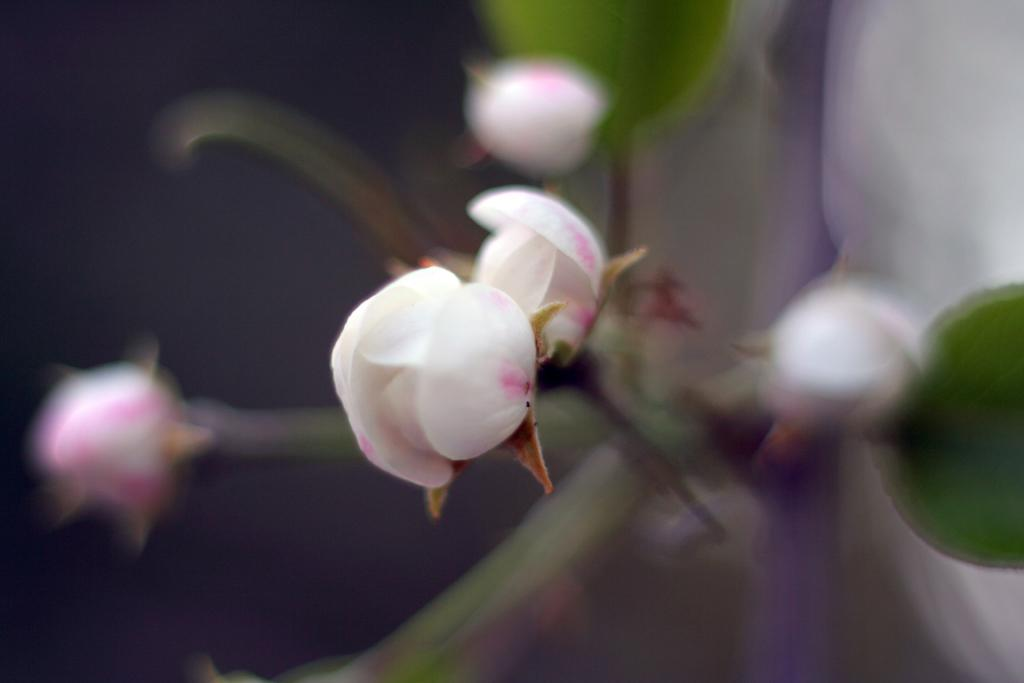What type of living organisms can be seen in the image? There are flowers and a plant visible in the image. What is the color of the background in the image? The background of the image is dark in color. Can you tell if the image was taken during the day or night? The image may have been taken during the night, given the dark background. Can you see any jellyfish swimming in the image? There are no jellyfish present in the image; it features flowers and a plant. Is there any indication that someone is driving in the image? There is no indication of driving or any vehicle in the image. 